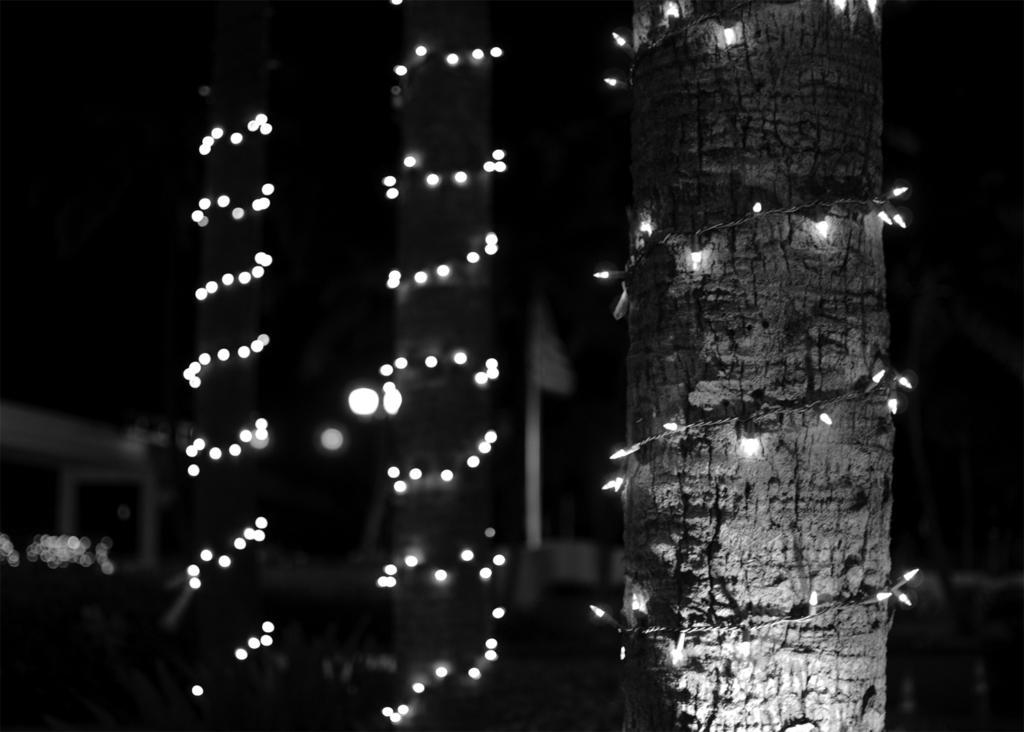Please provide a concise description of this image. In this image we can see the trunks of trees rounded with the decor lights. 